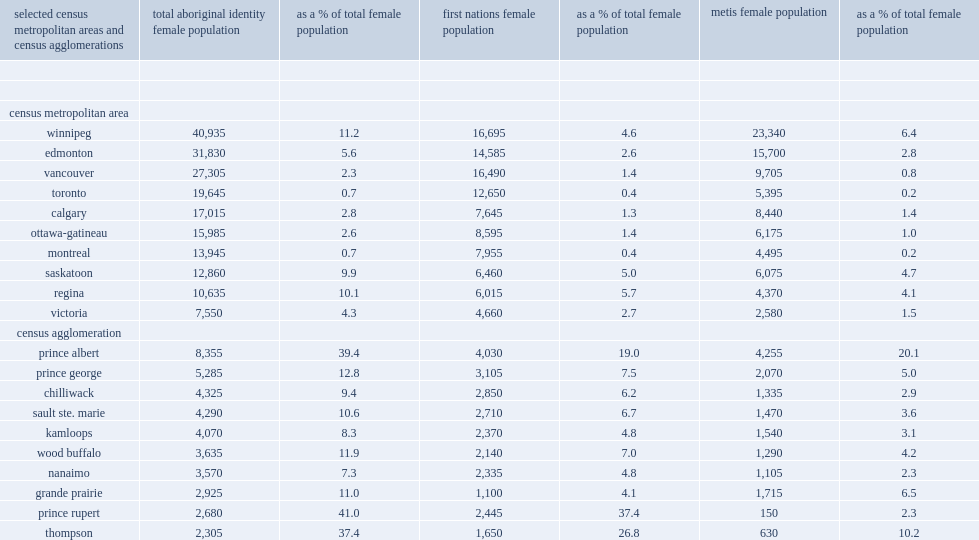How many percentages of the total female population in winnipeg was aboriginal? 11.2. How many percentages of the total female population in both regina and saskatoon was aboriginal? 10.1. How many percentages did aboriginal women and girls account for of the female population in edmonton? 5.6. How many percentages did aboriginal women and girls account for of the female population in victoria? 4.3. In 2011, how many aboriginal women and girls lived in winnipeg? 40935.0. In 2011, how many aboriginal women and girls lived in edmonton? 31830.0. In 2011, how many aboriginal women and girls lived in vancouver? 27305.0. In 2011, how many aboriginal women and girls lived in toronto? 19645.0. In 2011, what was the census agglomerations (cas) with the largest numbers of aboriginal females were prince albert? 8355.0. In 2011, what was the census agglomerations (cas) with the numbers of aboriginal females were prince george? 5285.0. In 2011, what was the census agglomerations (cas) with the numbers of aboriginal females were chilliwack? 4325.0. In 2011, what was the census agglomerations (cas) with the numbers of aboriginal females were sault ste. marie? 4290.0. In 2011, what was the census agglomerations (cas) with the numbers of aboriginal females were kamloops? 4070.0. In 2011, how many percent did aboriginal women and girls make up of all females in prince rupert? 41.0. In 2011, how many percent did aboriginal women and girls make up of all females in prince albert? 39.4. In 2011, how many percent did aboriginal women and girls make up of all females in thompson? 37.4. 